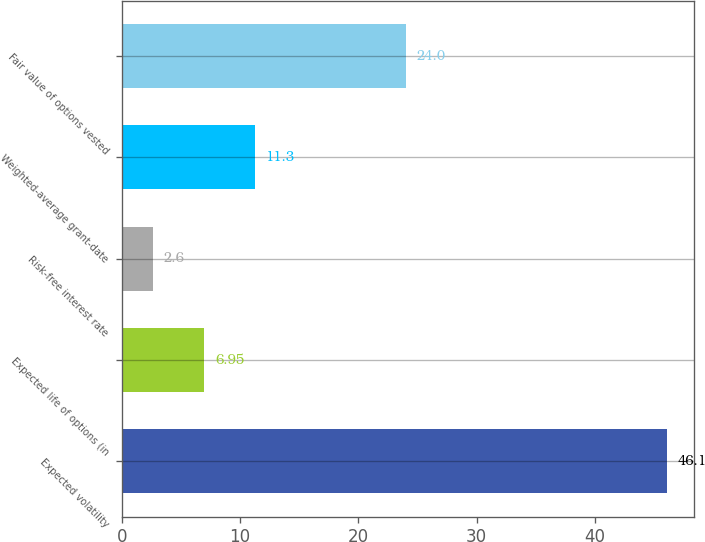Convert chart to OTSL. <chart><loc_0><loc_0><loc_500><loc_500><bar_chart><fcel>Expected volatility<fcel>Expected life of options (in<fcel>Risk-free interest rate<fcel>Weighted-average grant-date<fcel>Fair value of options vested<nl><fcel>46.1<fcel>6.95<fcel>2.6<fcel>11.3<fcel>24<nl></chart> 